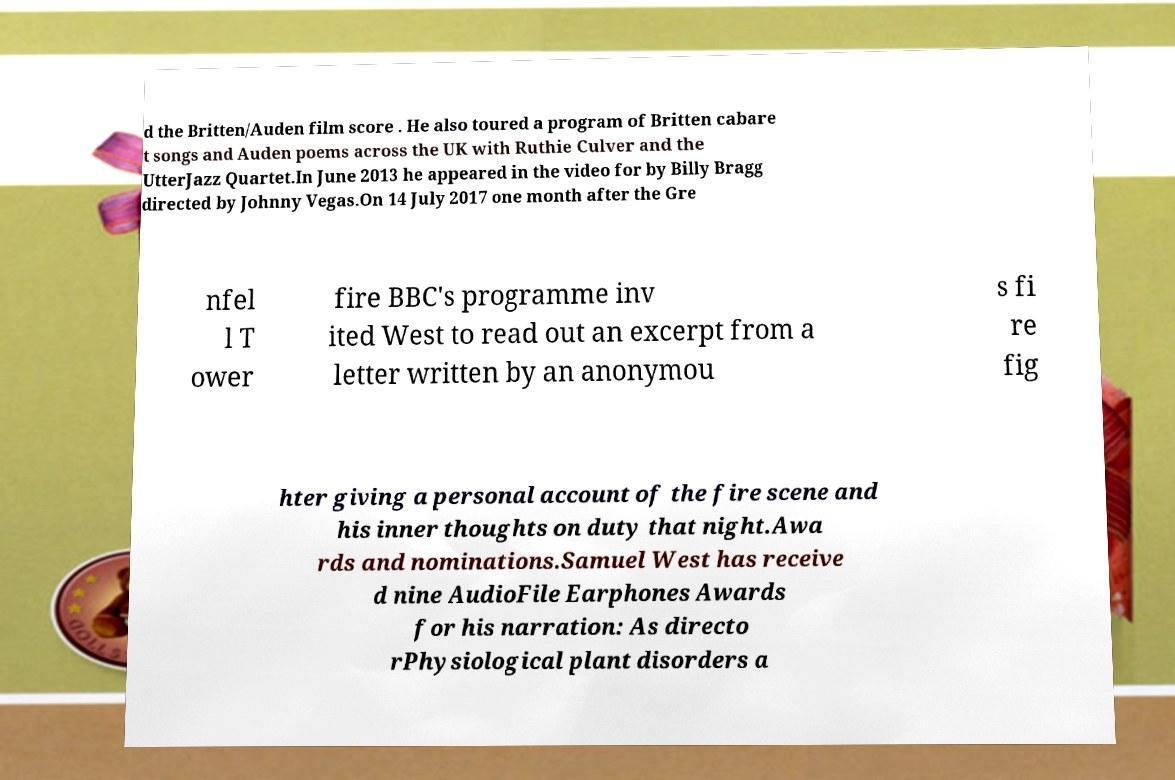I need the written content from this picture converted into text. Can you do that? d the Britten/Auden film score . He also toured a program of Britten cabare t songs and Auden poems across the UK with Ruthie Culver and the UtterJazz Quartet.In June 2013 he appeared in the video for by Billy Bragg directed by Johnny Vegas.On 14 July 2017 one month after the Gre nfel l T ower fire BBC's programme inv ited West to read out an excerpt from a letter written by an anonymou s fi re fig hter giving a personal account of the fire scene and his inner thoughts on duty that night.Awa rds and nominations.Samuel West has receive d nine AudioFile Earphones Awards for his narration: As directo rPhysiological plant disorders a 